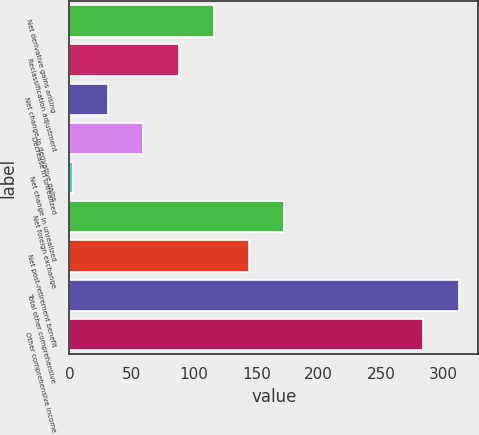<chart> <loc_0><loc_0><loc_500><loc_500><bar_chart><fcel>Net derivative gains arising<fcel>Reclassification adjustment<fcel>Net change in derivative gains<fcel>Decrease in unrealized<fcel>Net change in unrealized<fcel>Net foreign exchange<fcel>Net post-retirement benefit<fcel>Total other comprehensive<fcel>Other comprehensive income<nl><fcel>115.8<fcel>87.6<fcel>31.2<fcel>59.4<fcel>3<fcel>172.2<fcel>144<fcel>312.2<fcel>284<nl></chart> 